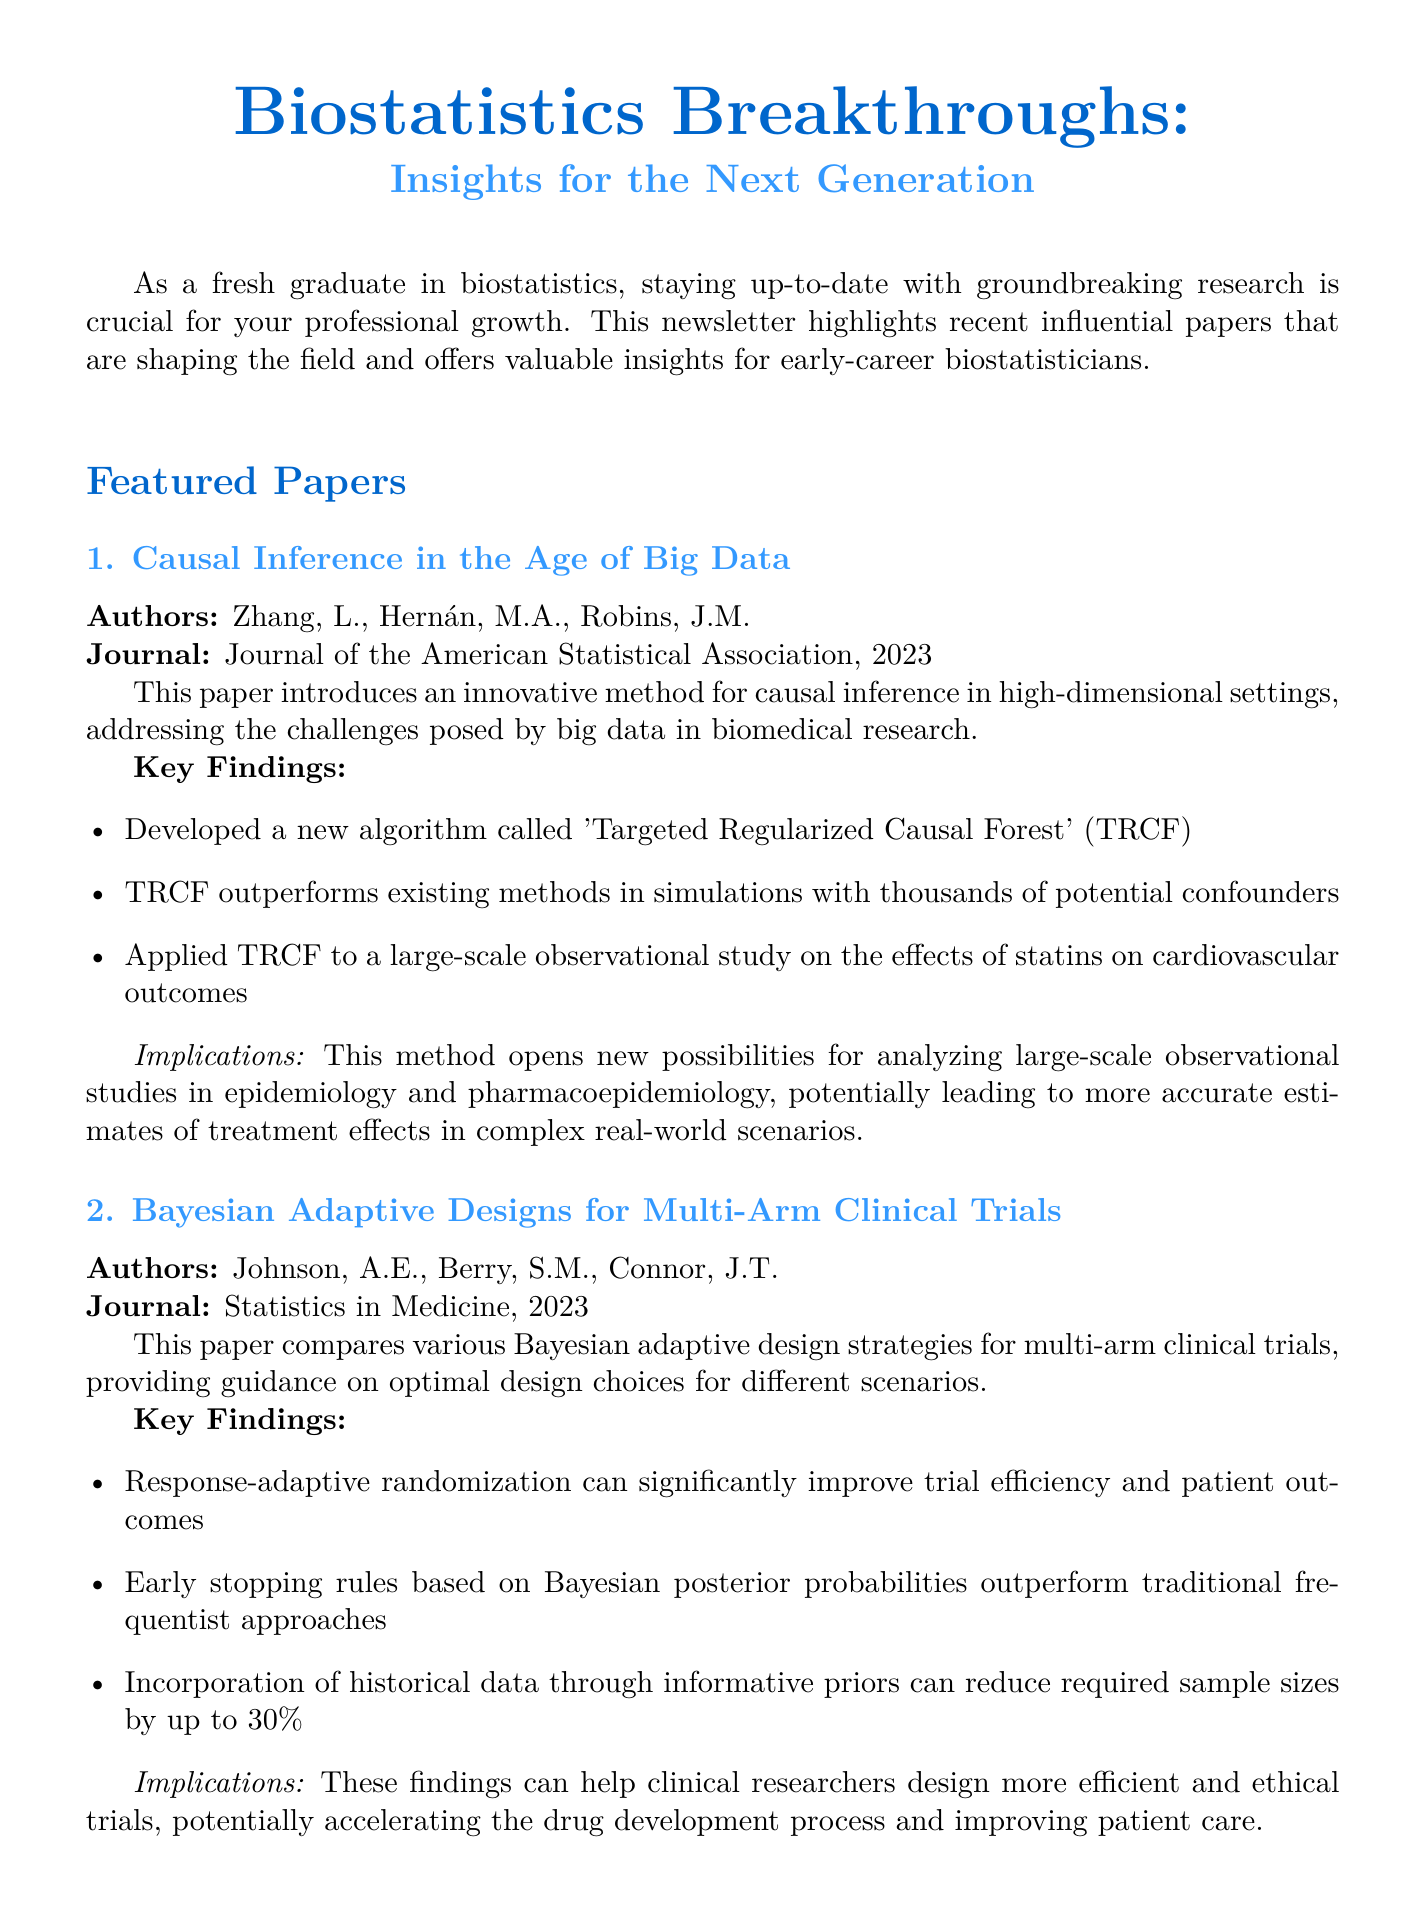What is the title of the newsletter? The title of the newsletter is mentioned at the top of the document.
Answer: Biostatistics Breakthroughs: Insights for the Next Generation Who are the authors of the paper on causal inference? The authors of the paper are listed under the featured paper section about causal inference.
Answer: Zhang, L., Hernán, M.A., Robins, J.M In which journal was the Bayesian adaptive designs paper published? The journal details are provided immediately following the title of each featured paper.
Answer: Statistics in Medicine What year was the paper on personalized medicine published? The publication year is stated next to the journal name for each featured paper.
Answer: 2022 What algorithm is introduced in the paper about causal inference? The key findings section lists this information clearly under the respective paper summary.
Answer: Targeted Regularized Causal Forest What is a key finding of the Bayesian adaptive designs paper? The key findings are listed and can be found in bullet points under the respective paper summary.
Answer: Response-adaptive randomization can significantly improve trial efficiency and patient outcomes What implication does the causal inference method have for future studies? The implications section summarizes the potential impact of the research methods discussed.
Answer: This method opens new possibilities for analyzing large-scale observational studies in epidemiology and pharmacoepidemiology How many learning resources are listed in the newsletter? The learning resources section details this information clearly by listing three distinct resources.
Answer: 3 Which institution provides the online course on advanced causal inference methods? The provider of the course is mentioned right after the title in the learning resources section.
Answer: Harvard University via edX 